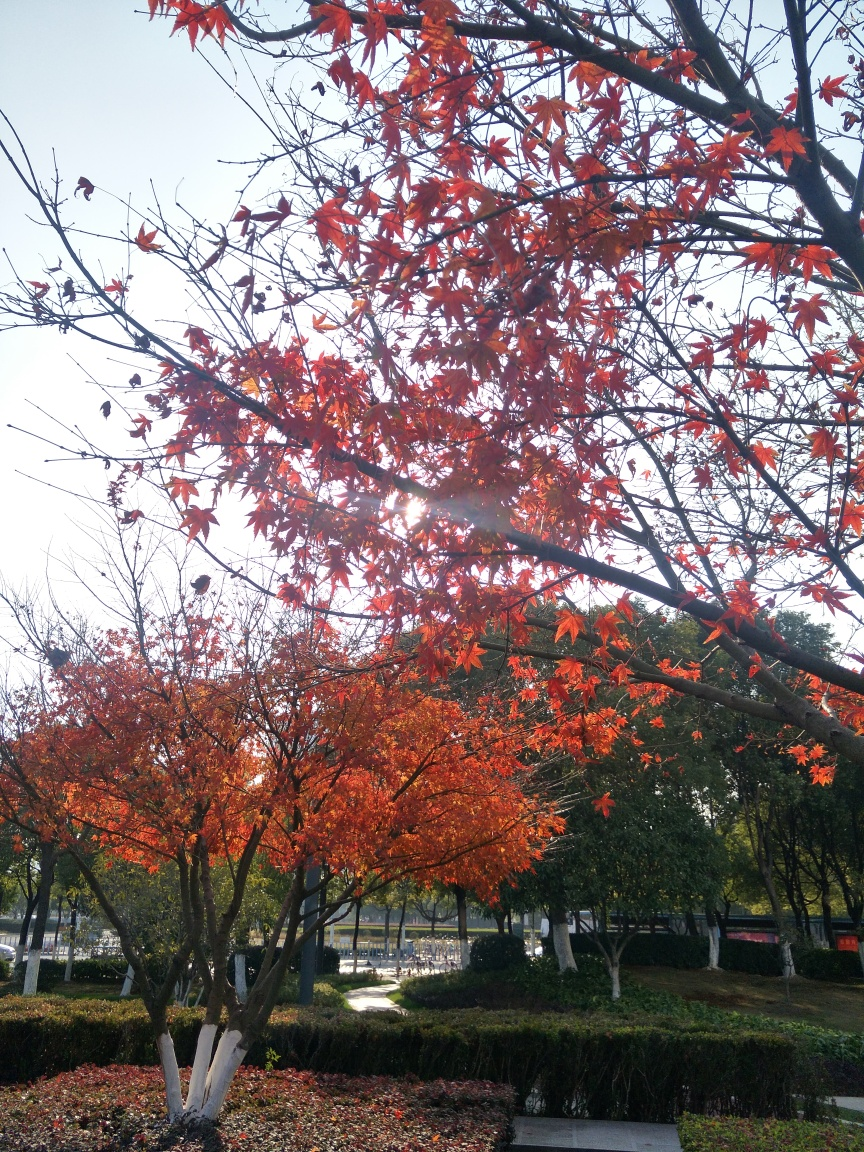Can you describe the season depicted in this image? The image showcases a setting during autumn, as indicated by the rich, warm colors of the leaves ranging from deep reds to bright oranges. The trees are in the process of shedding their leaves, which is typical of the fall season. 